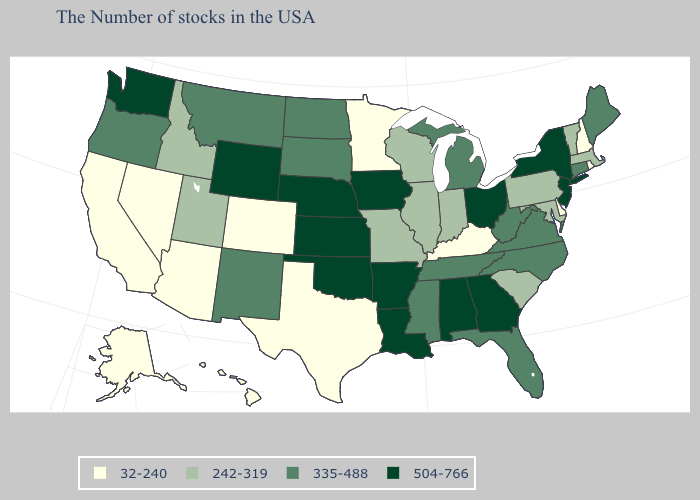What is the value of Connecticut?
Write a very short answer. 335-488. Name the states that have a value in the range 335-488?
Short answer required. Maine, Connecticut, Virginia, North Carolina, West Virginia, Florida, Michigan, Tennessee, Mississippi, South Dakota, North Dakota, New Mexico, Montana, Oregon. Among the states that border Rhode Island , does Massachusetts have the lowest value?
Answer briefly. Yes. What is the value of New Mexico?
Quick response, please. 335-488. What is the lowest value in the USA?
Be succinct. 32-240. Name the states that have a value in the range 242-319?
Quick response, please. Massachusetts, Vermont, Maryland, Pennsylvania, South Carolina, Indiana, Wisconsin, Illinois, Missouri, Utah, Idaho. Among the states that border Oklahoma , which have the highest value?
Short answer required. Arkansas, Kansas. What is the highest value in the West ?
Concise answer only. 504-766. Name the states that have a value in the range 504-766?
Keep it brief. New York, New Jersey, Ohio, Georgia, Alabama, Louisiana, Arkansas, Iowa, Kansas, Nebraska, Oklahoma, Wyoming, Washington. What is the highest value in states that border West Virginia?
Quick response, please. 504-766. What is the value of Mississippi?
Quick response, please. 335-488. What is the lowest value in states that border Vermont?
Quick response, please. 32-240. What is the value of Illinois?
Write a very short answer. 242-319. Does Nebraska have a lower value than Alaska?
Concise answer only. No. What is the lowest value in the USA?
Short answer required. 32-240. 